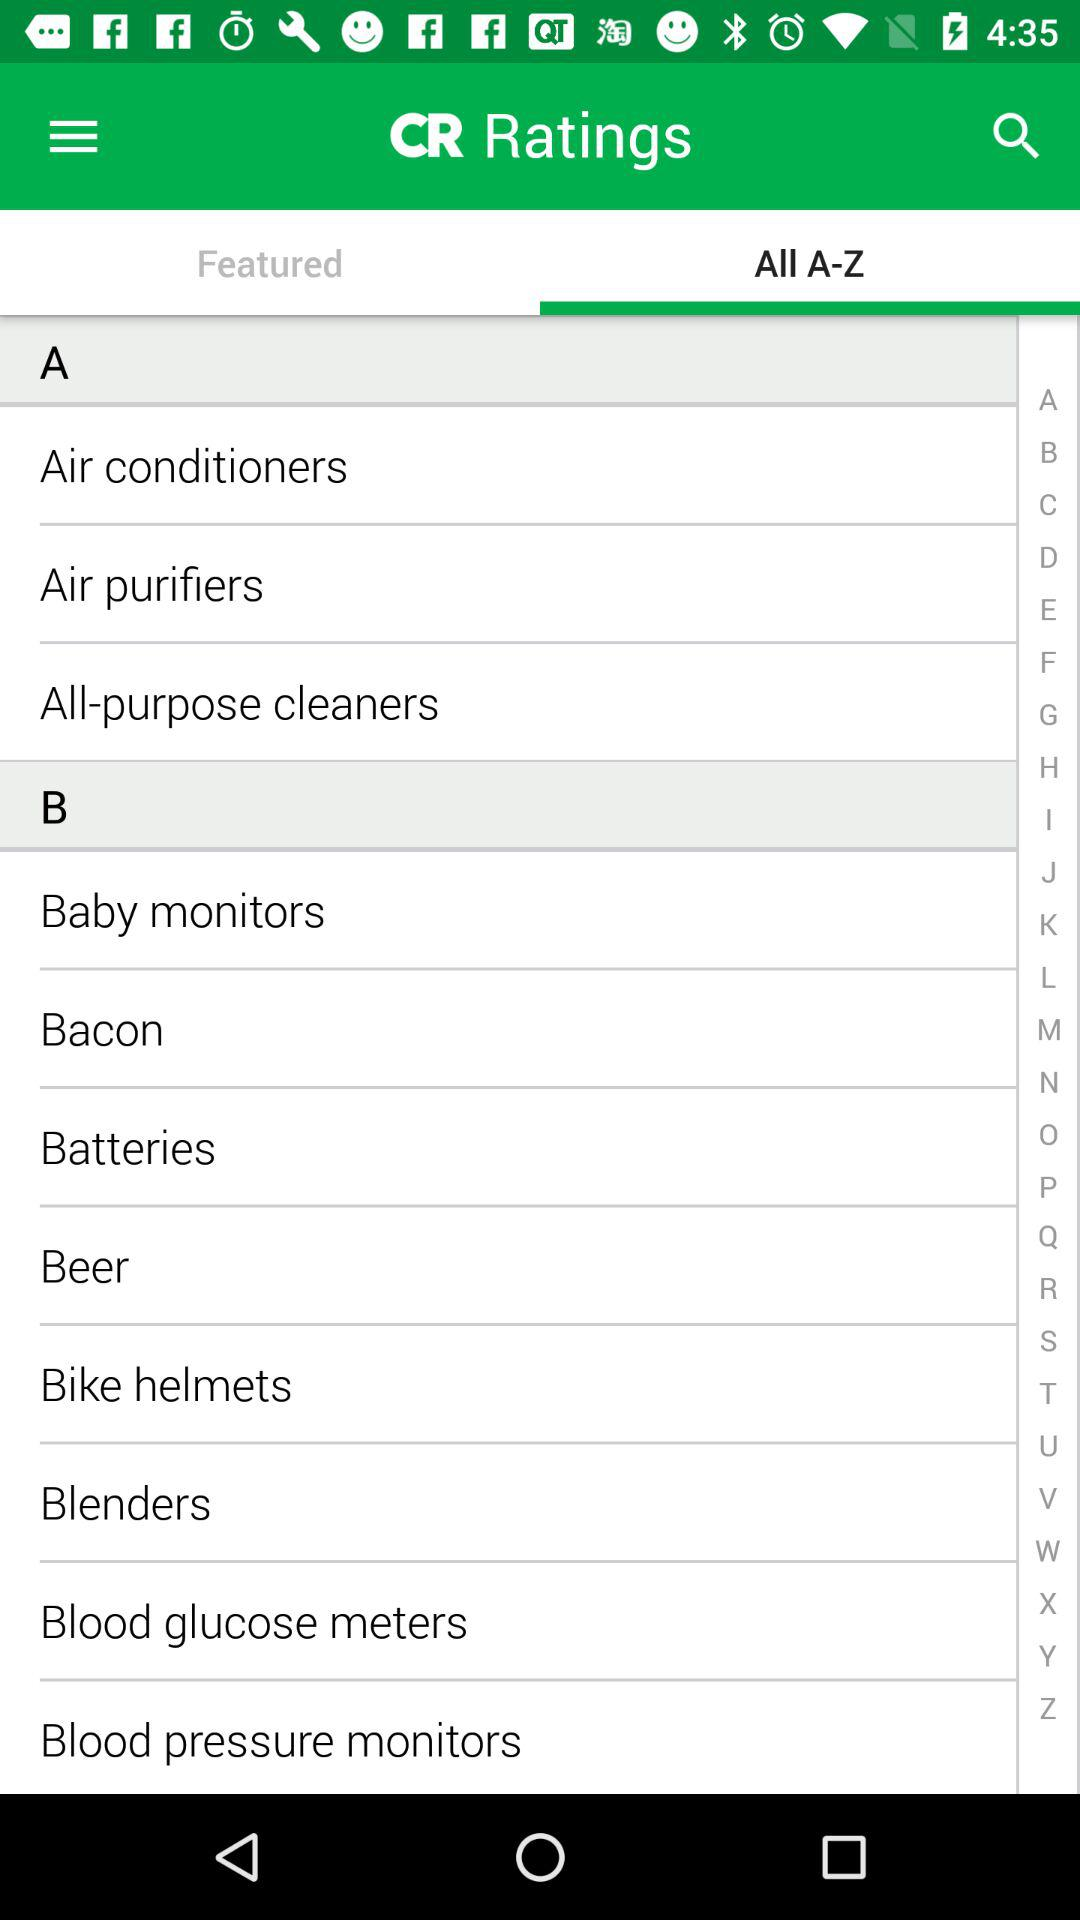Which tab is selected? The selected tab is "All A-Z". 